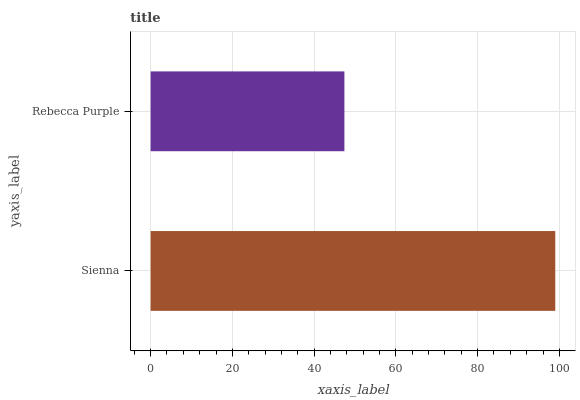Is Rebecca Purple the minimum?
Answer yes or no. Yes. Is Sienna the maximum?
Answer yes or no. Yes. Is Rebecca Purple the maximum?
Answer yes or no. No. Is Sienna greater than Rebecca Purple?
Answer yes or no. Yes. Is Rebecca Purple less than Sienna?
Answer yes or no. Yes. Is Rebecca Purple greater than Sienna?
Answer yes or no. No. Is Sienna less than Rebecca Purple?
Answer yes or no. No. Is Sienna the high median?
Answer yes or no. Yes. Is Rebecca Purple the low median?
Answer yes or no. Yes. Is Rebecca Purple the high median?
Answer yes or no. No. Is Sienna the low median?
Answer yes or no. No. 